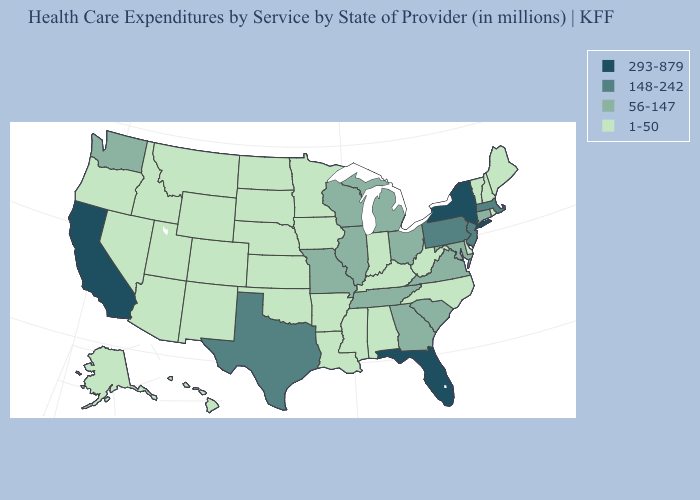Name the states that have a value in the range 56-147?
Give a very brief answer. Connecticut, Georgia, Illinois, Maryland, Michigan, Missouri, Ohio, South Carolina, Tennessee, Virginia, Washington, Wisconsin. Does Michigan have the lowest value in the USA?
Be succinct. No. Name the states that have a value in the range 56-147?
Answer briefly. Connecticut, Georgia, Illinois, Maryland, Michigan, Missouri, Ohio, South Carolina, Tennessee, Virginia, Washington, Wisconsin. Name the states that have a value in the range 293-879?
Keep it brief. California, Florida, New York. Name the states that have a value in the range 293-879?
Short answer required. California, Florida, New York. Name the states that have a value in the range 293-879?
Quick response, please. California, Florida, New York. Does Oklahoma have the highest value in the South?
Write a very short answer. No. What is the lowest value in states that border Michigan?
Keep it brief. 1-50. Does Maine have the lowest value in the Northeast?
Quick response, please. Yes. Name the states that have a value in the range 56-147?
Give a very brief answer. Connecticut, Georgia, Illinois, Maryland, Michigan, Missouri, Ohio, South Carolina, Tennessee, Virginia, Washington, Wisconsin. Does the map have missing data?
Give a very brief answer. No. Does Pennsylvania have the lowest value in the USA?
Keep it brief. No. Which states have the lowest value in the MidWest?
Short answer required. Indiana, Iowa, Kansas, Minnesota, Nebraska, North Dakota, South Dakota. Name the states that have a value in the range 148-242?
Be succinct. Massachusetts, New Jersey, Pennsylvania, Texas. Name the states that have a value in the range 293-879?
Answer briefly. California, Florida, New York. 